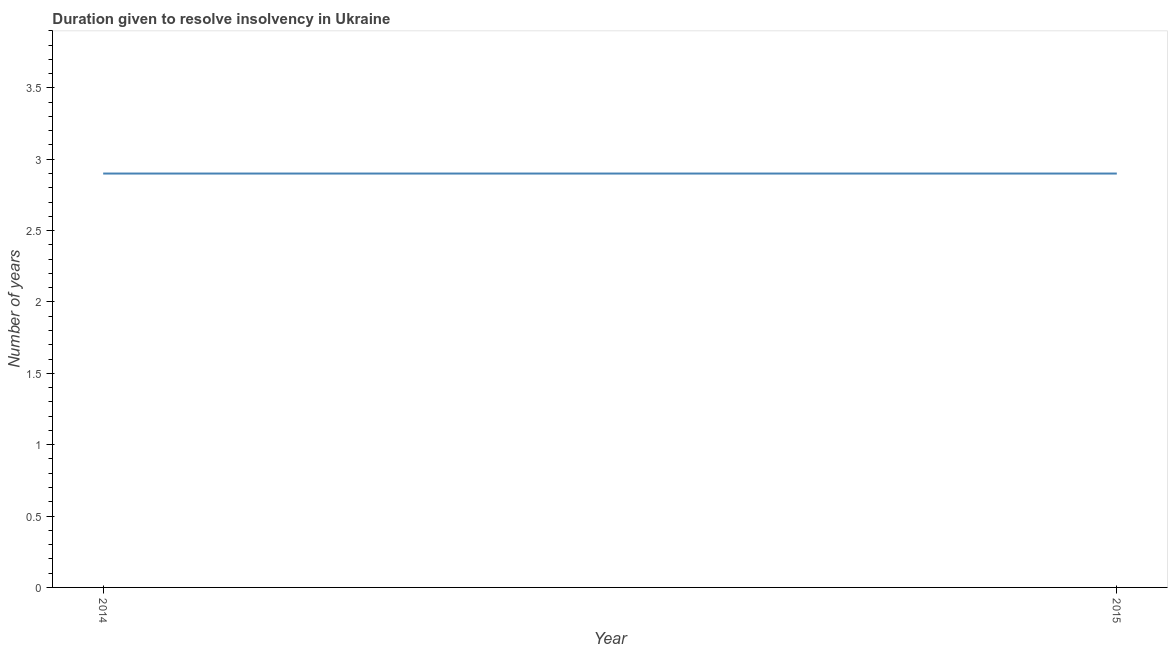Across all years, what is the minimum number of years to resolve insolvency?
Your response must be concise. 2.9. In how many years, is the number of years to resolve insolvency greater than 0.8 ?
Provide a short and direct response. 2. What is the ratio of the number of years to resolve insolvency in 2014 to that in 2015?
Make the answer very short. 1. Is the number of years to resolve insolvency in 2014 less than that in 2015?
Provide a succinct answer. No. Are the values on the major ticks of Y-axis written in scientific E-notation?
Provide a succinct answer. No. What is the title of the graph?
Provide a succinct answer. Duration given to resolve insolvency in Ukraine. What is the label or title of the X-axis?
Your answer should be very brief. Year. What is the label or title of the Y-axis?
Make the answer very short. Number of years. What is the difference between the Number of years in 2014 and 2015?
Your answer should be very brief. 0. 